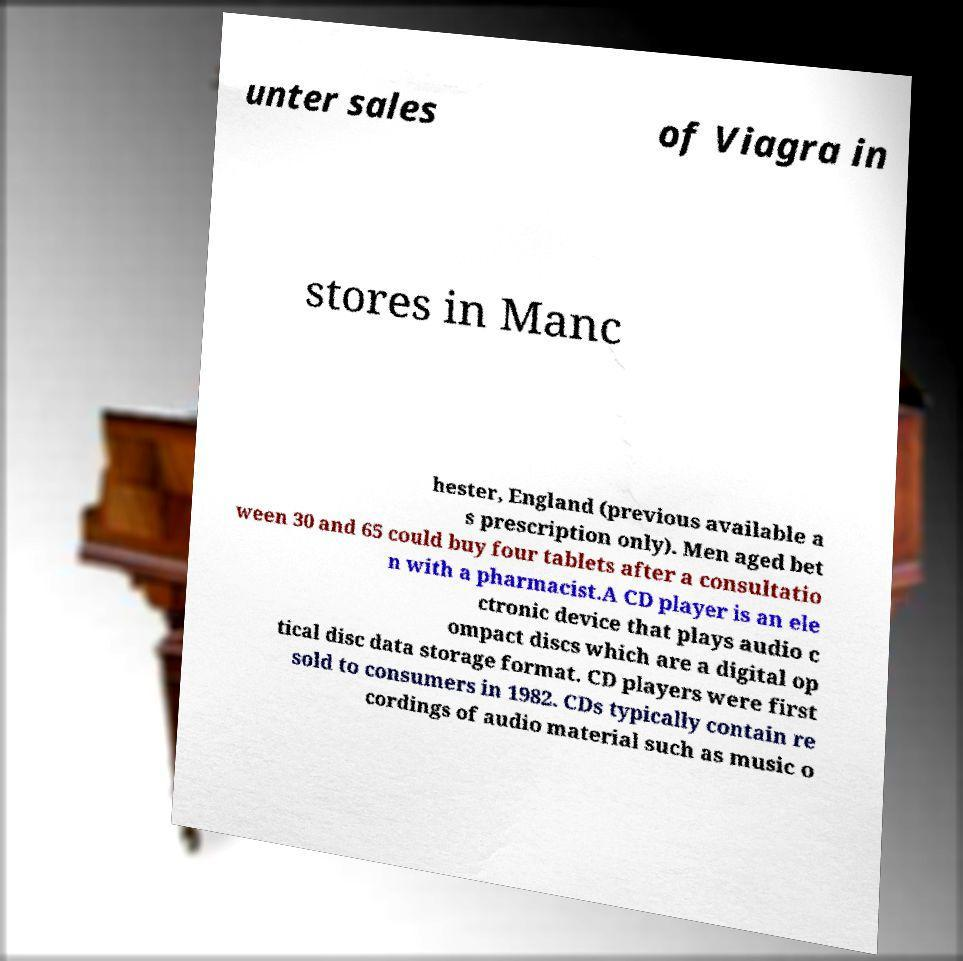Can you read and provide the text displayed in the image?This photo seems to have some interesting text. Can you extract and type it out for me? unter sales of Viagra in stores in Manc hester, England (previous available a s prescription only). Men aged bet ween 30 and 65 could buy four tablets after a consultatio n with a pharmacist.A CD player is an ele ctronic device that plays audio c ompact discs which are a digital op tical disc data storage format. CD players were first sold to consumers in 1982. CDs typically contain re cordings of audio material such as music o 